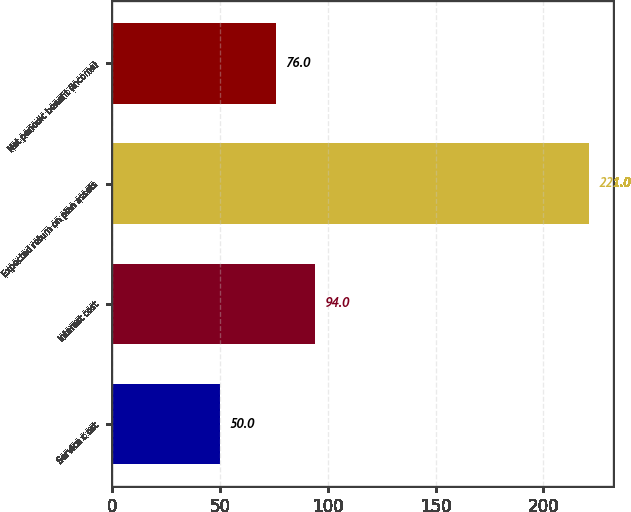<chart> <loc_0><loc_0><loc_500><loc_500><bar_chart><fcel>Service c ost<fcel>Interest cost<fcel>Expected return on plan assets<fcel>Net periodic benefit (income)<nl><fcel>50<fcel>94<fcel>221<fcel>76<nl></chart> 